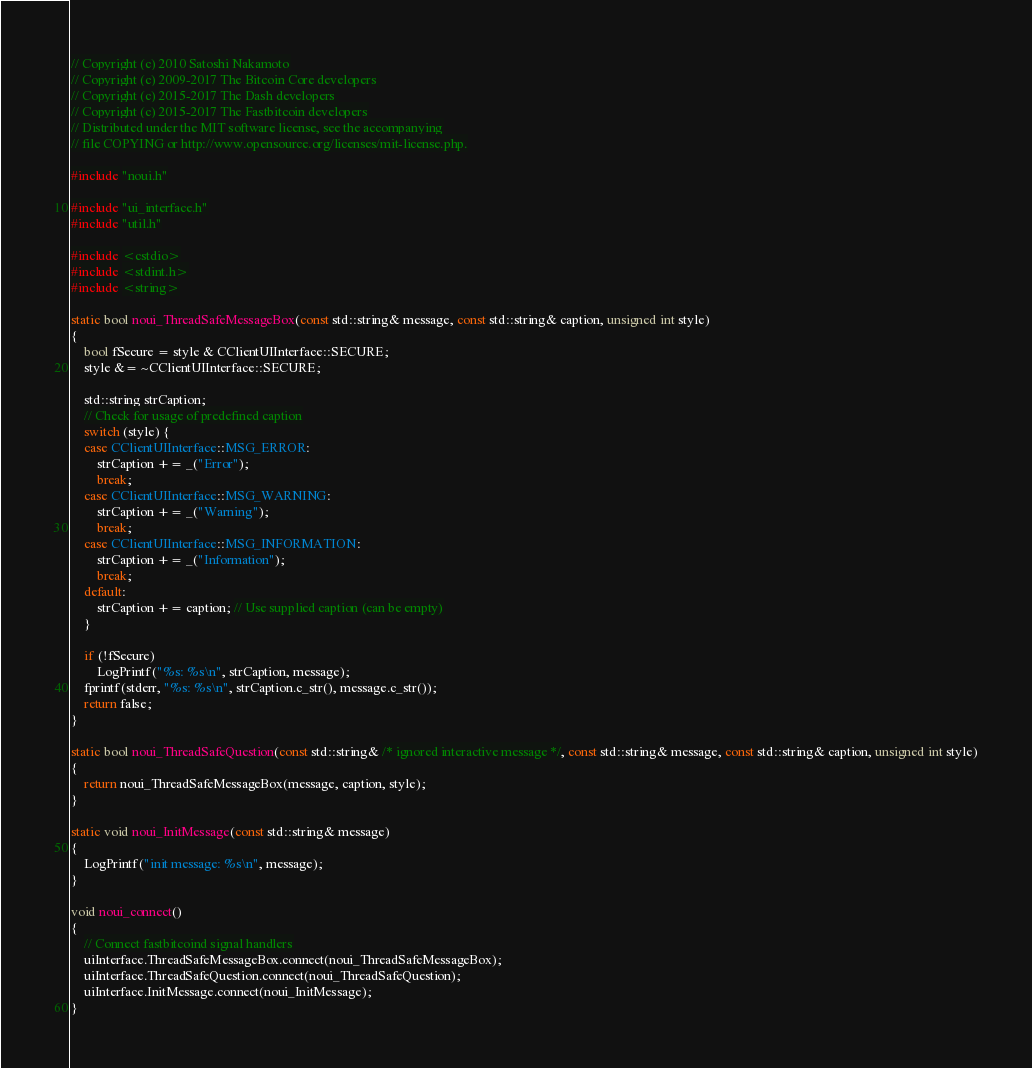<code> <loc_0><loc_0><loc_500><loc_500><_C++_>// Copyright (c) 2010 Satoshi Nakamoto
// Copyright (c) 2009-2017 The Bitcoin Core developers 
// Copyright (c) 2015-2017 The Dash developers 
// Copyright (c) 2015-2017 The Fastbitcoin developers
// Distributed under the MIT software license, see the accompanying
// file COPYING or http://www.opensource.org/licenses/mit-license.php.

#include "noui.h"

#include "ui_interface.h"
#include "util.h"

#include <cstdio>
#include <stdint.h>
#include <string>

static bool noui_ThreadSafeMessageBox(const std::string& message, const std::string& caption, unsigned int style)
{
    bool fSecure = style & CClientUIInterface::SECURE;
    style &= ~CClientUIInterface::SECURE;

    std::string strCaption;
    // Check for usage of predefined caption
    switch (style) {
    case CClientUIInterface::MSG_ERROR:
        strCaption += _("Error");
        break;
    case CClientUIInterface::MSG_WARNING:
        strCaption += _("Warning");
        break;
    case CClientUIInterface::MSG_INFORMATION:
        strCaption += _("Information");
        break;
    default:
        strCaption += caption; // Use supplied caption (can be empty)
    }

    if (!fSecure)
        LogPrintf("%s: %s\n", strCaption, message);
    fprintf(stderr, "%s: %s\n", strCaption.c_str(), message.c_str());
    return false;
}

static bool noui_ThreadSafeQuestion(const std::string& /* ignored interactive message */, const std::string& message, const std::string& caption, unsigned int style)
{
    return noui_ThreadSafeMessageBox(message, caption, style);
}

static void noui_InitMessage(const std::string& message)
{
    LogPrintf("init message: %s\n", message);
}

void noui_connect()
{
    // Connect fastbitcoind signal handlers
    uiInterface.ThreadSafeMessageBox.connect(noui_ThreadSafeMessageBox);
    uiInterface.ThreadSafeQuestion.connect(noui_ThreadSafeQuestion);
    uiInterface.InitMessage.connect(noui_InitMessage);
}
</code> 